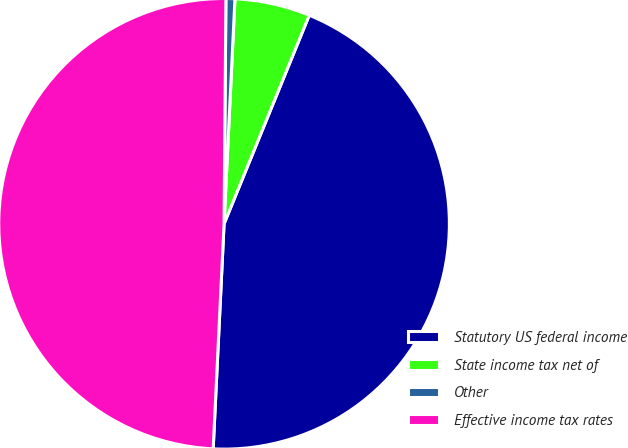<chart> <loc_0><loc_0><loc_500><loc_500><pie_chart><fcel>Statutory US federal income<fcel>State income tax net of<fcel>Other<fcel>Effective income tax rates<nl><fcel>44.6%<fcel>5.4%<fcel>0.64%<fcel>49.36%<nl></chart> 